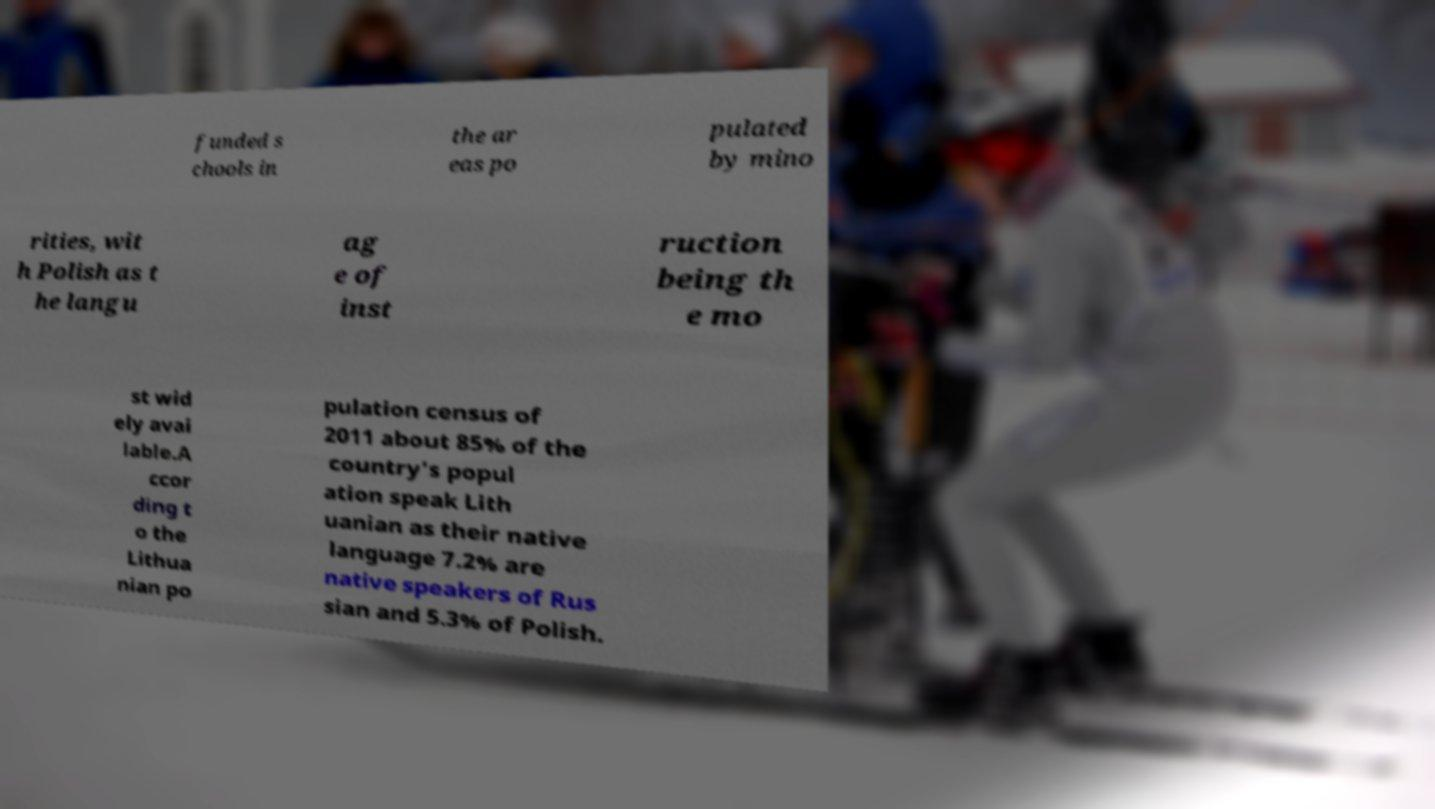Please read and relay the text visible in this image. What does it say? funded s chools in the ar eas po pulated by mino rities, wit h Polish as t he langu ag e of inst ruction being th e mo st wid ely avai lable.A ccor ding t o the Lithua nian po pulation census of 2011 about 85% of the country's popul ation speak Lith uanian as their native language 7.2% are native speakers of Rus sian and 5.3% of Polish. 